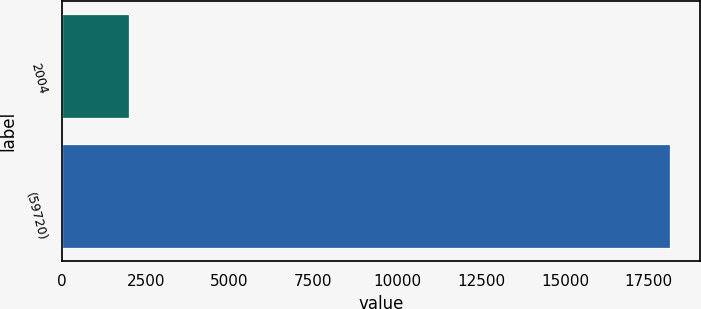Convert chart. <chart><loc_0><loc_0><loc_500><loc_500><bar_chart><fcel>2004<fcel>(59720)<nl><fcel>2002<fcel>18131<nl></chart> 